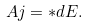Convert formula to latex. <formula><loc_0><loc_0><loc_500><loc_500>A j = { * } d E .</formula> 